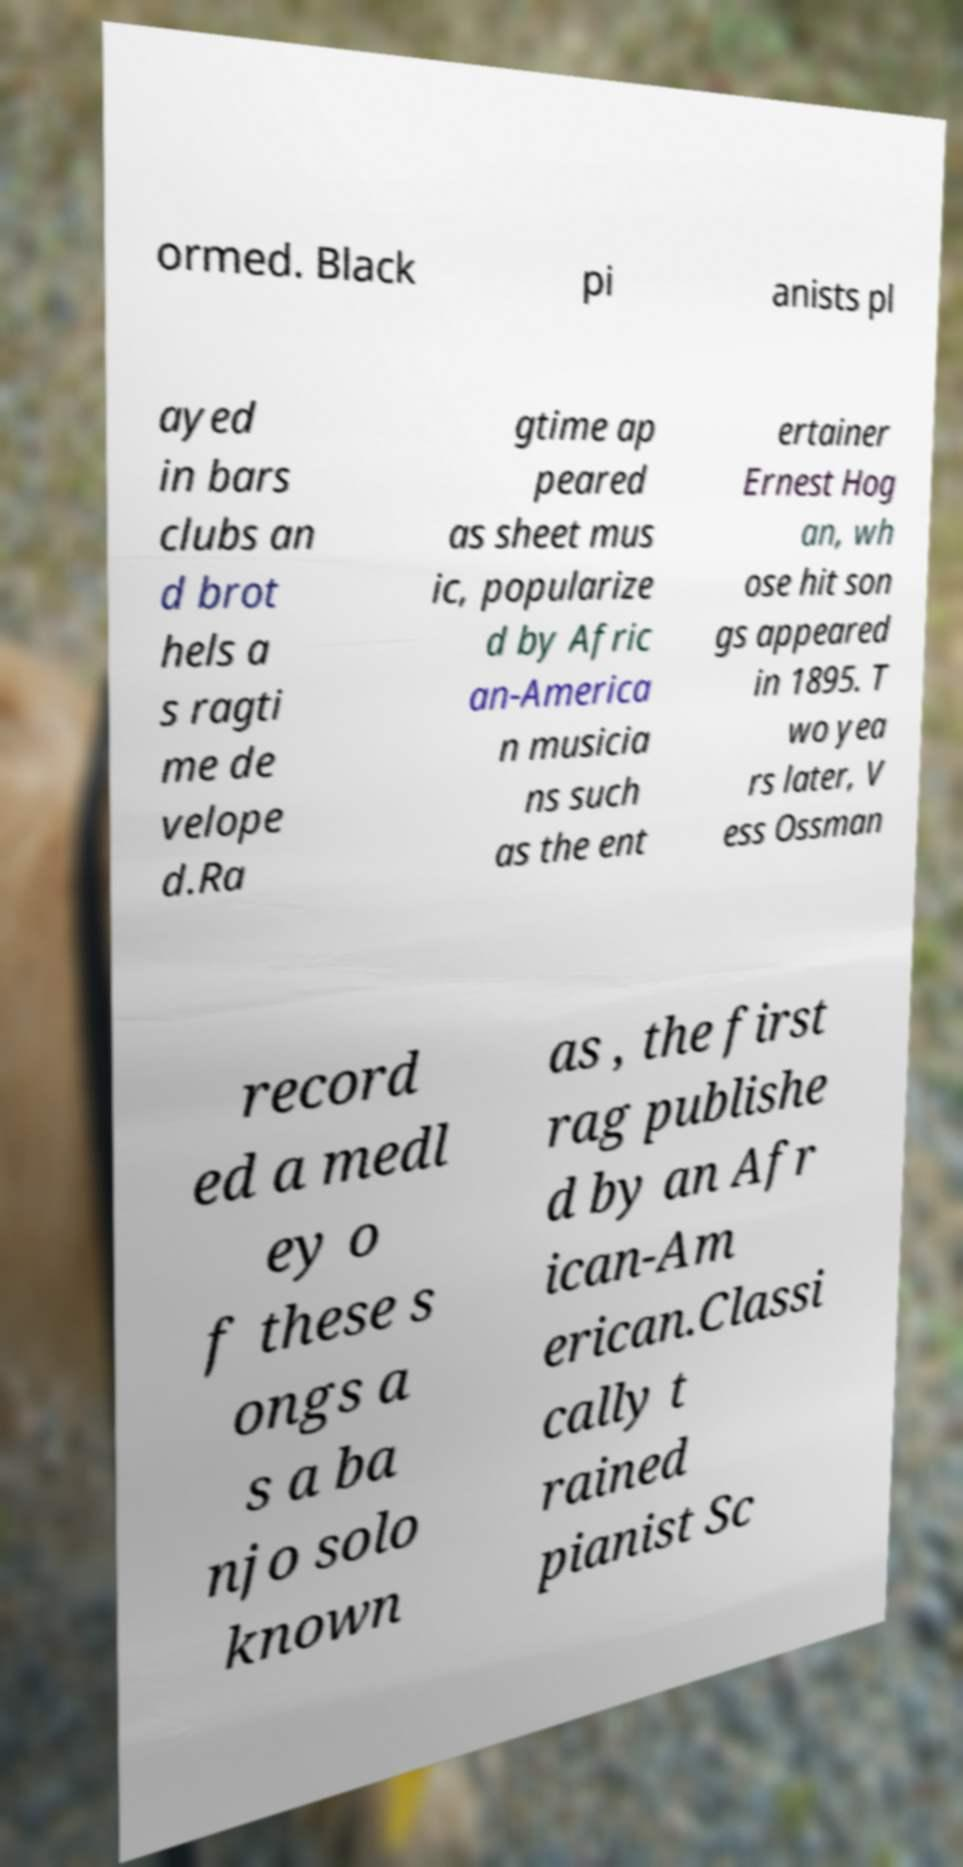Could you extract and type out the text from this image? ormed. Black pi anists pl ayed in bars clubs an d brot hels a s ragti me de velope d.Ra gtime ap peared as sheet mus ic, popularize d by Afric an-America n musicia ns such as the ent ertainer Ernest Hog an, wh ose hit son gs appeared in 1895. T wo yea rs later, V ess Ossman record ed a medl ey o f these s ongs a s a ba njo solo known as , the first rag publishe d by an Afr ican-Am erican.Classi cally t rained pianist Sc 